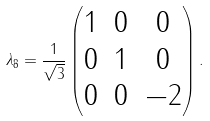Convert formula to latex. <formula><loc_0><loc_0><loc_500><loc_500>\lambda _ { 8 } = \frac { 1 } { \sqrt { 3 } } \begin{pmatrix} 1 & 0 & 0 \\ 0 & 1 & 0 \\ 0 & 0 & - 2 \end{pmatrix} .</formula> 